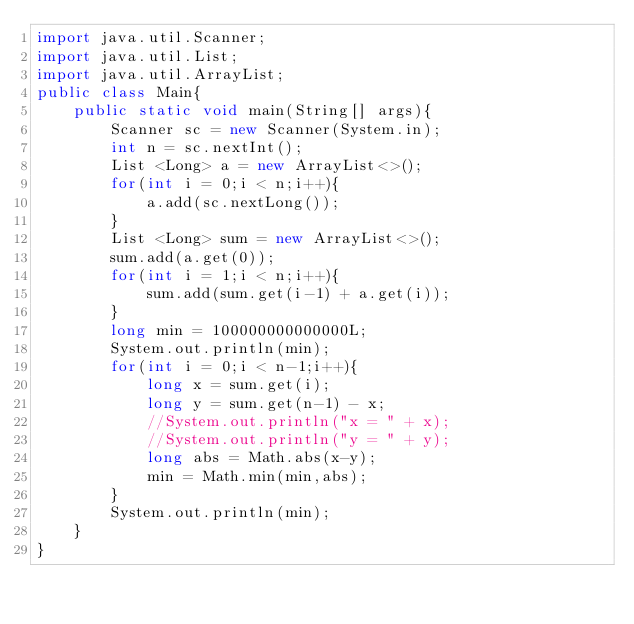Convert code to text. <code><loc_0><loc_0><loc_500><loc_500><_Java_>import java.util.Scanner;
import java.util.List;
import java.util.ArrayList;
public class Main{
    public static void main(String[] args){
        Scanner sc = new Scanner(System.in);
        int n = sc.nextInt();
        List <Long> a = new ArrayList<>();
        for(int i = 0;i < n;i++){
            a.add(sc.nextLong());
        }
        List <Long> sum = new ArrayList<>();
        sum.add(a.get(0));
        for(int i = 1;i < n;i++){
            sum.add(sum.get(i-1) + a.get(i));
        }
        long min = 100000000000000L;
        System.out.println(min);
        for(int i = 0;i < n-1;i++){
            long x = sum.get(i);
            long y = sum.get(n-1) - x;
            //System.out.println("x = " + x);
            //System.out.println("y = " + y);
            long abs = Math.abs(x-y);
            min = Math.min(min,abs);
        }
        System.out.println(min);
    }
}
</code> 